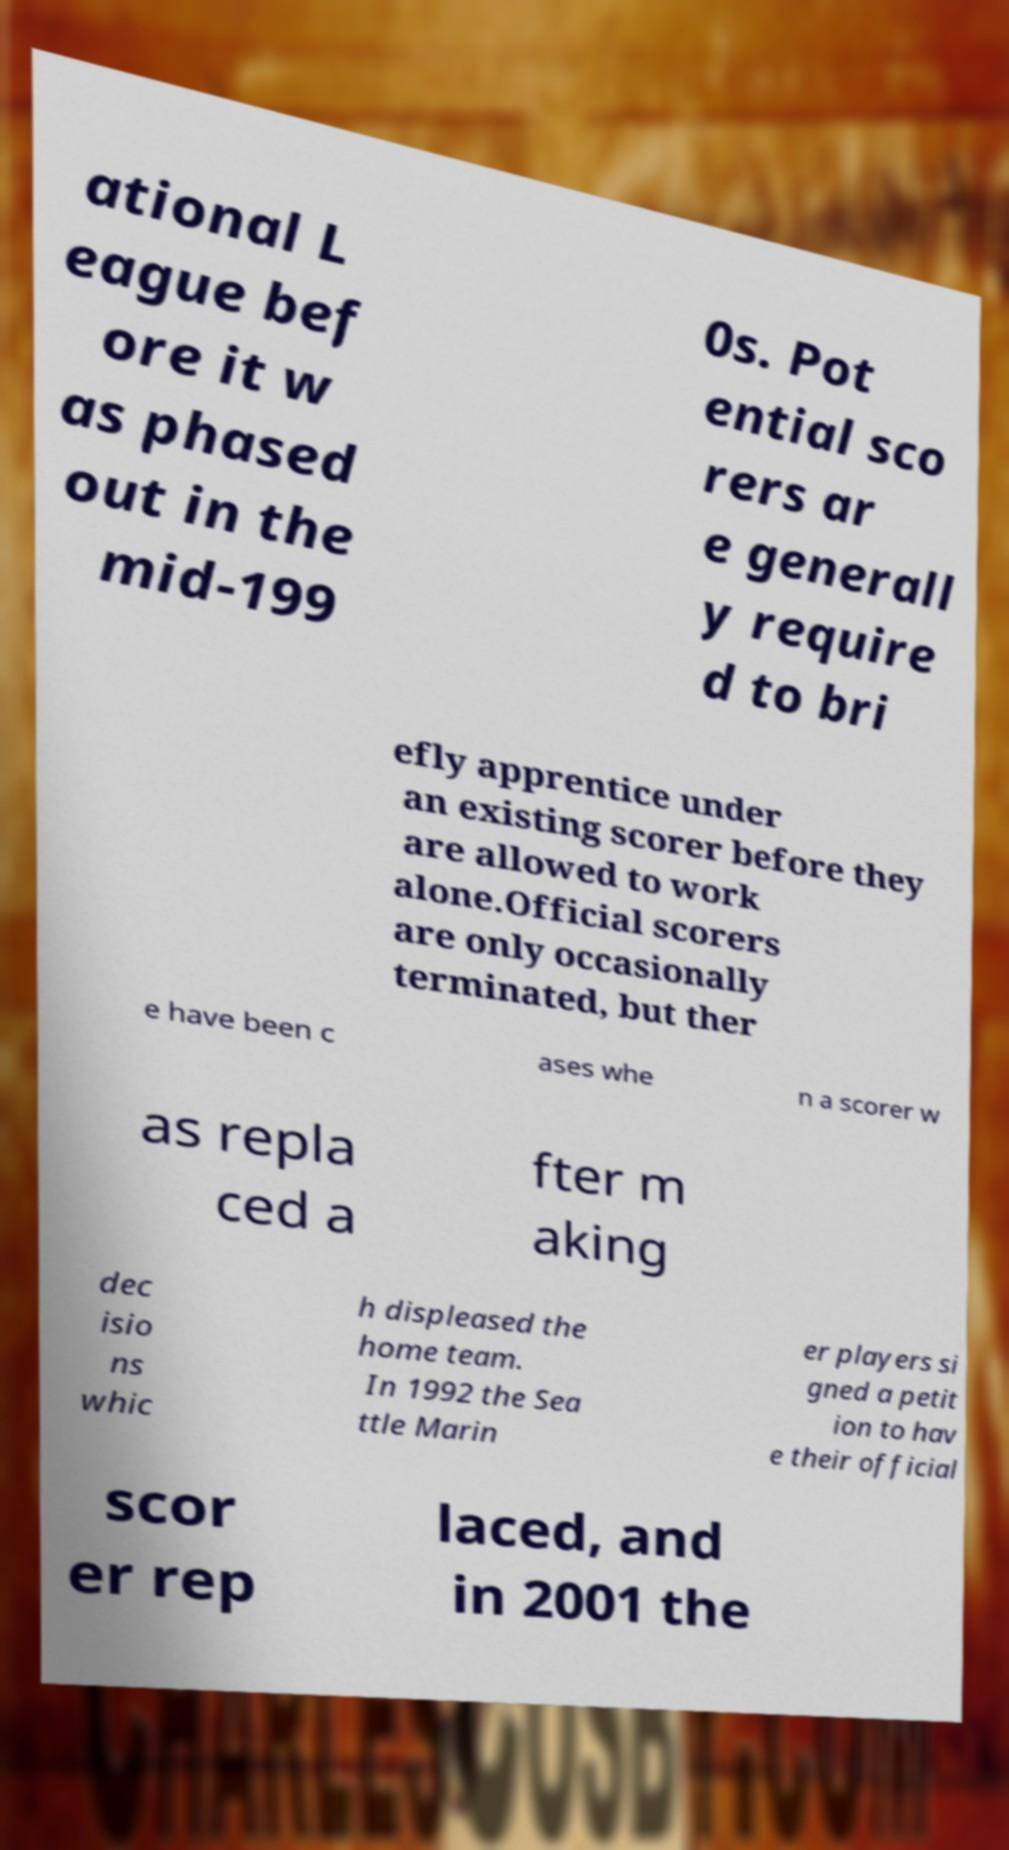What messages or text are displayed in this image? I need them in a readable, typed format. ational L eague bef ore it w as phased out in the mid-199 0s. Pot ential sco rers ar e generall y require d to bri efly apprentice under an existing scorer before they are allowed to work alone.Official scorers are only occasionally terminated, but ther e have been c ases whe n a scorer w as repla ced a fter m aking dec isio ns whic h displeased the home team. In 1992 the Sea ttle Marin er players si gned a petit ion to hav e their official scor er rep laced, and in 2001 the 